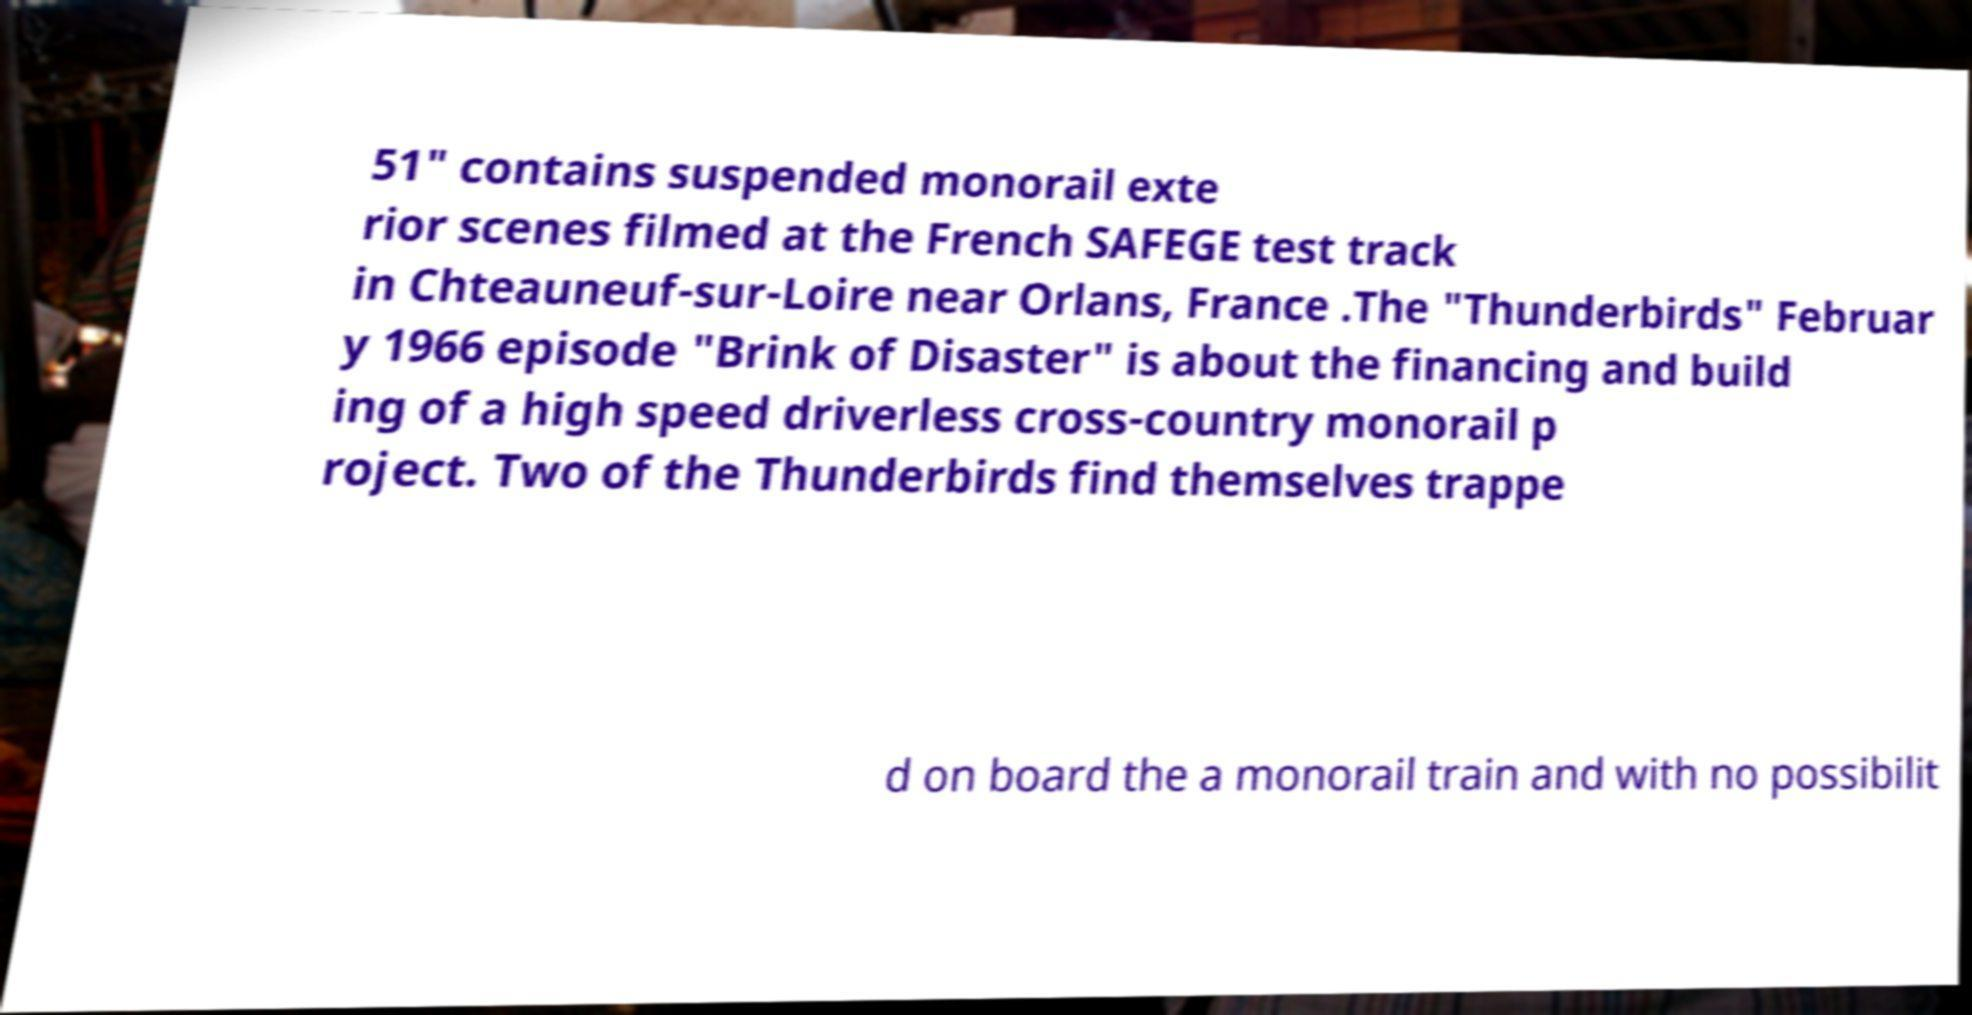There's text embedded in this image that I need extracted. Can you transcribe it verbatim? 51" contains suspended monorail exte rior scenes filmed at the French SAFEGE test track in Chteauneuf-sur-Loire near Orlans, France .The "Thunderbirds" Februar y 1966 episode "Brink of Disaster" is about the financing and build ing of a high speed driverless cross-country monorail p roject. Two of the Thunderbirds find themselves trappe d on board the a monorail train and with no possibilit 